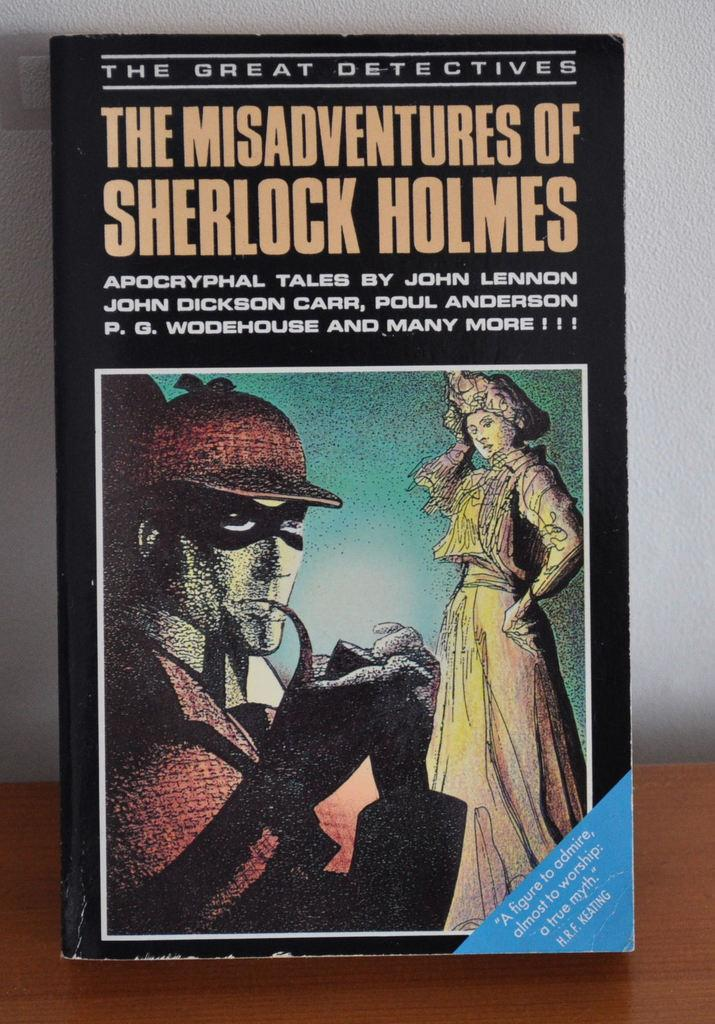<image>
Describe the image concisely. The Misadventures of Sherlock Holmes is standing up on a table. 